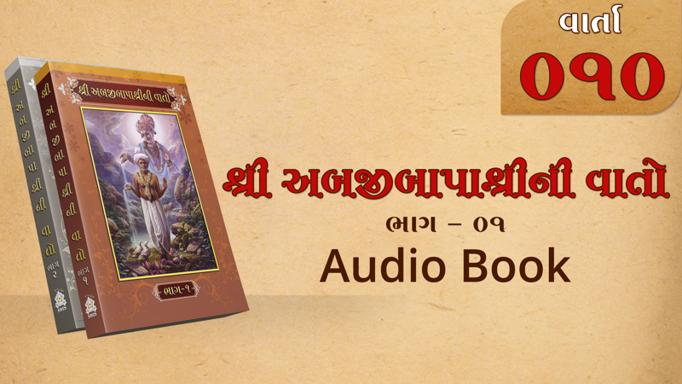What format is available for this book? The book is available in an audio format, as indicated by the mention of "Audio Book." 